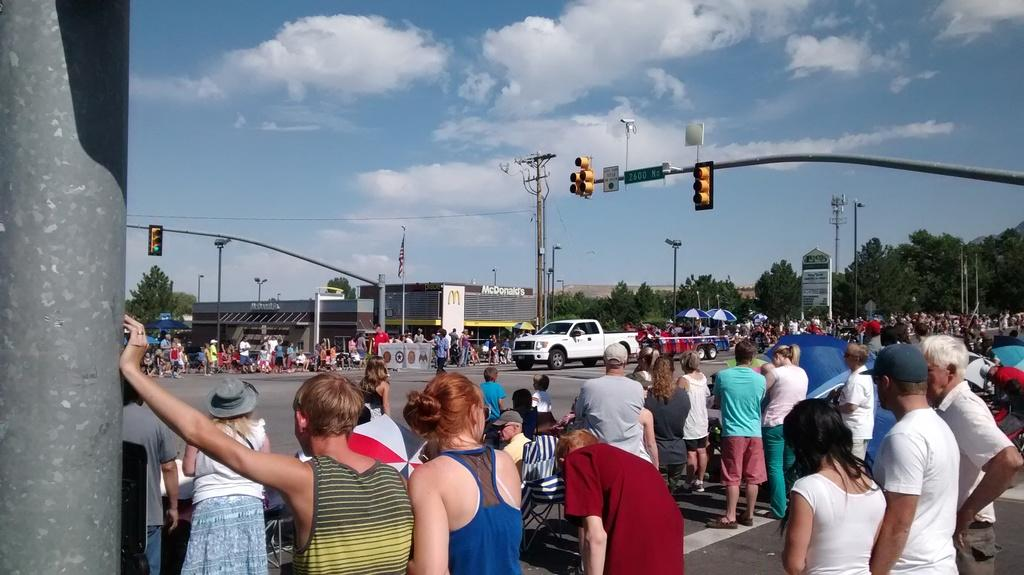What can be seen in the image involving human presence? There are people standing in the image. What mode of transportation is present in the image? There is a car in the image. What type of natural environment is visible in the image? There are trees in the image. What is visible in the background of the image? The sky is visible in the image. Is there a shop selling plants in the image? There is no shop or plantation present in the image; it only features people, a car, trees, and the sky. What type of wilderness can be seen in the image? There is no wilderness depicted in the image; it shows a more urban or suburban setting with a car and trees. 